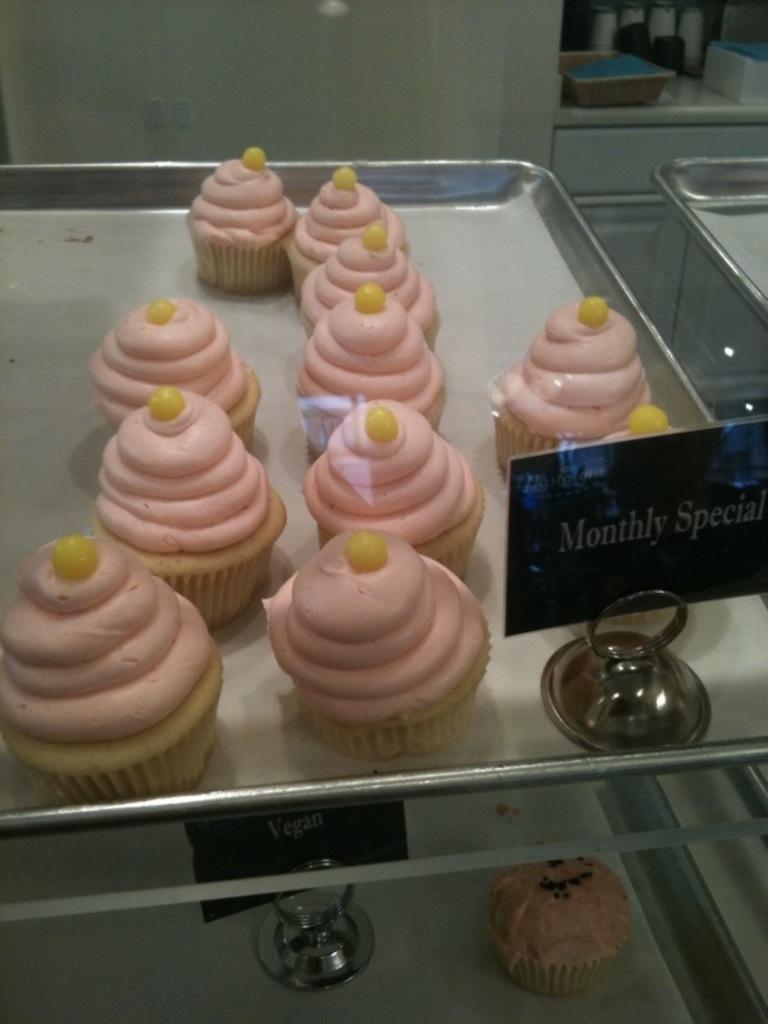Could you give a brief overview of what you see in this image? In this image there are trays. On the trays there are cupcakes. Beside the cupcakes there is a small board with text. At the top there is a wall. In the top right there is a basket on the wall. 